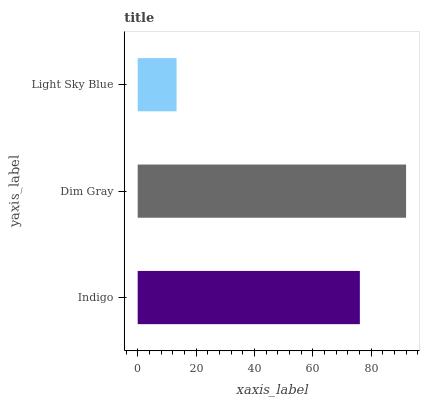Is Light Sky Blue the minimum?
Answer yes or no. Yes. Is Dim Gray the maximum?
Answer yes or no. Yes. Is Dim Gray the minimum?
Answer yes or no. No. Is Light Sky Blue the maximum?
Answer yes or no. No. Is Dim Gray greater than Light Sky Blue?
Answer yes or no. Yes. Is Light Sky Blue less than Dim Gray?
Answer yes or no. Yes. Is Light Sky Blue greater than Dim Gray?
Answer yes or no. No. Is Dim Gray less than Light Sky Blue?
Answer yes or no. No. Is Indigo the high median?
Answer yes or no. Yes. Is Indigo the low median?
Answer yes or no. Yes. Is Dim Gray the high median?
Answer yes or no. No. Is Light Sky Blue the low median?
Answer yes or no. No. 